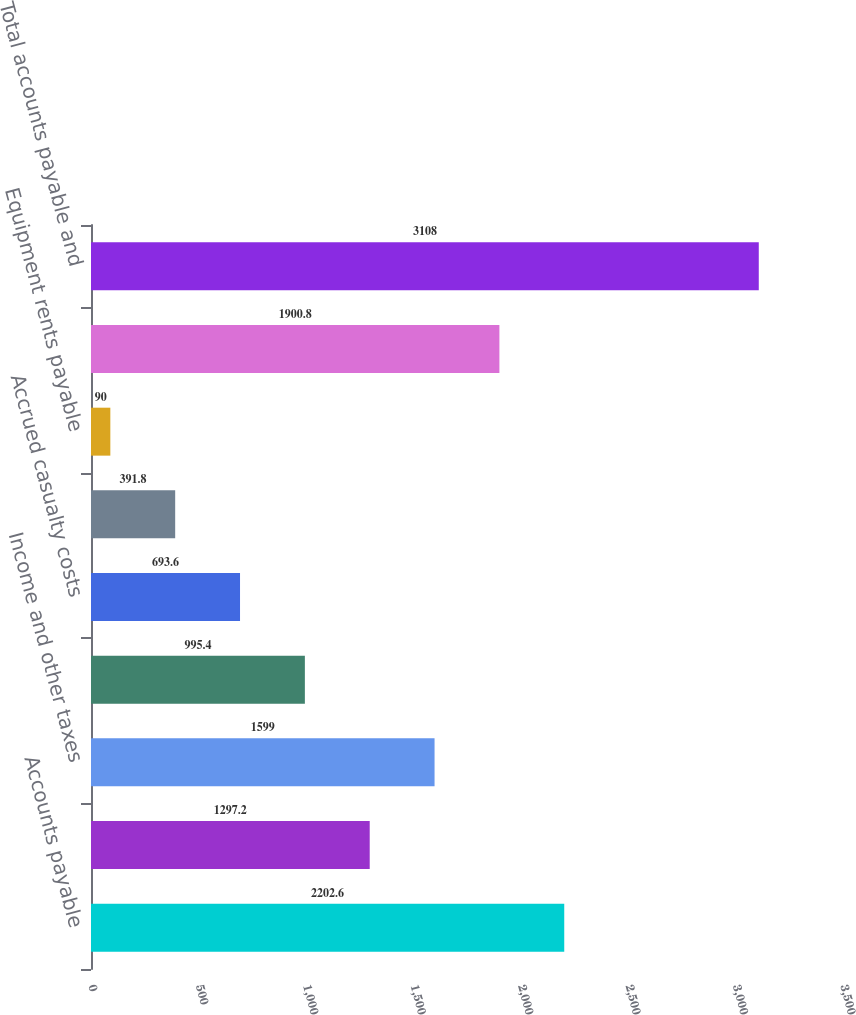<chart> <loc_0><loc_0><loc_500><loc_500><bar_chart><fcel>Accounts payable<fcel>Accrued wages and vacation<fcel>Income and other taxes<fcel>Dividends payable<fcel>Accrued casualty costs<fcel>Interest payable<fcel>Equipment rents payable<fcel>Other<fcel>Total accounts payable and<nl><fcel>2202.6<fcel>1297.2<fcel>1599<fcel>995.4<fcel>693.6<fcel>391.8<fcel>90<fcel>1900.8<fcel>3108<nl></chart> 